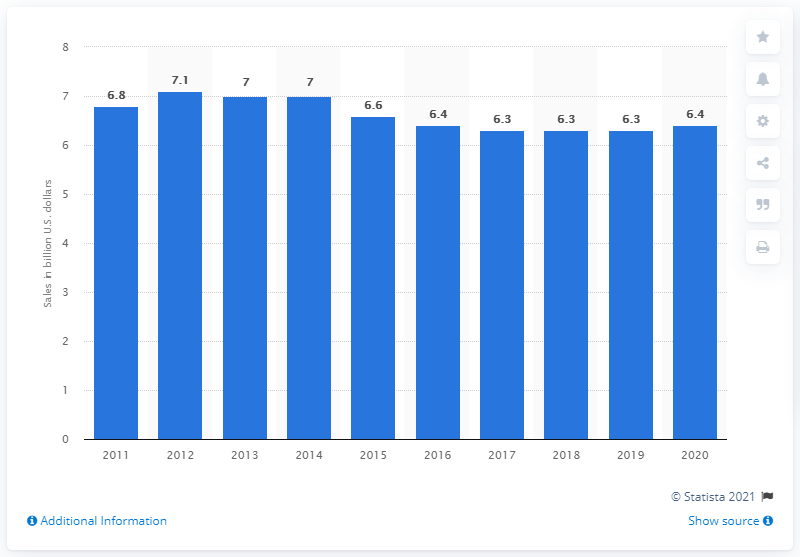Identify some key points in this picture. In the fiscal year 2020, Kimberly-Clark generated approximately 6.4 billion U.S. dollars in revenue from baby and child care products. 